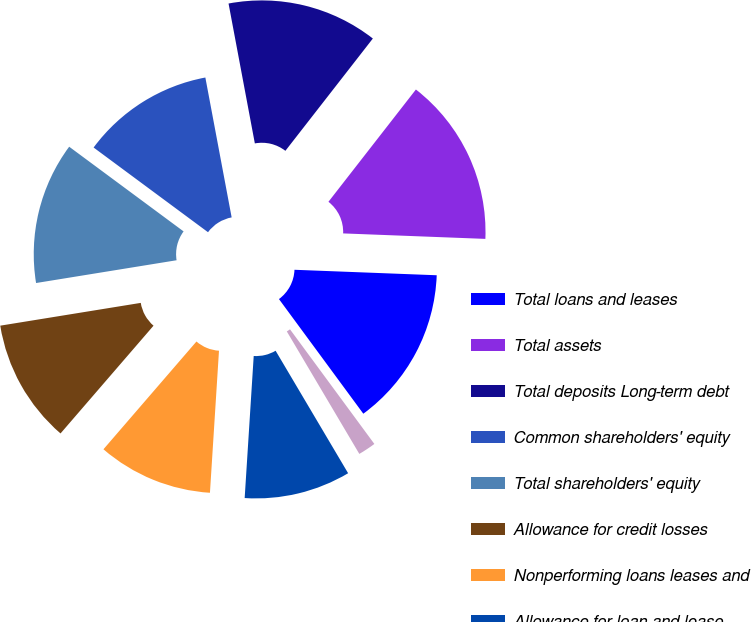Convert chart. <chart><loc_0><loc_0><loc_500><loc_500><pie_chart><fcel>Total loans and leases<fcel>Total assets<fcel>Total deposits Long-term debt<fcel>Common shareholders' equity<fcel>Total shareholders' equity<fcel>Allowance for credit losses<fcel>Nonperforming loans leases and<fcel>Allowance for loan and lease<fcel>Annualized net charge-offs and<nl><fcel>14.29%<fcel>15.08%<fcel>13.49%<fcel>11.9%<fcel>12.7%<fcel>11.11%<fcel>10.32%<fcel>9.52%<fcel>1.59%<nl></chart> 